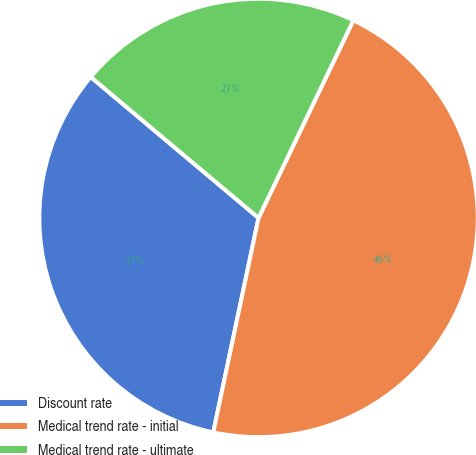Convert chart to OTSL. <chart><loc_0><loc_0><loc_500><loc_500><pie_chart><fcel>Discount rate<fcel>Medical trend rate - initial<fcel>Medical trend rate - ultimate<nl><fcel>32.81%<fcel>46.19%<fcel>21.0%<nl></chart> 